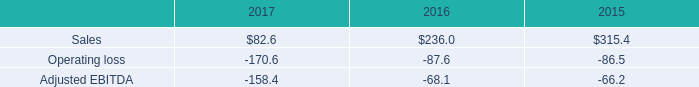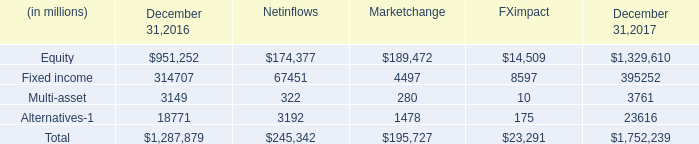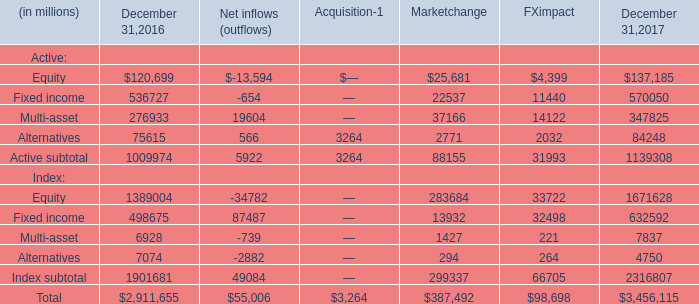In the year with largest amount of Equity in table 2, what's the increasing rate of Fixed income? 
Computations: ((570050 - 536727) / 536727)
Answer: 0.06209. 